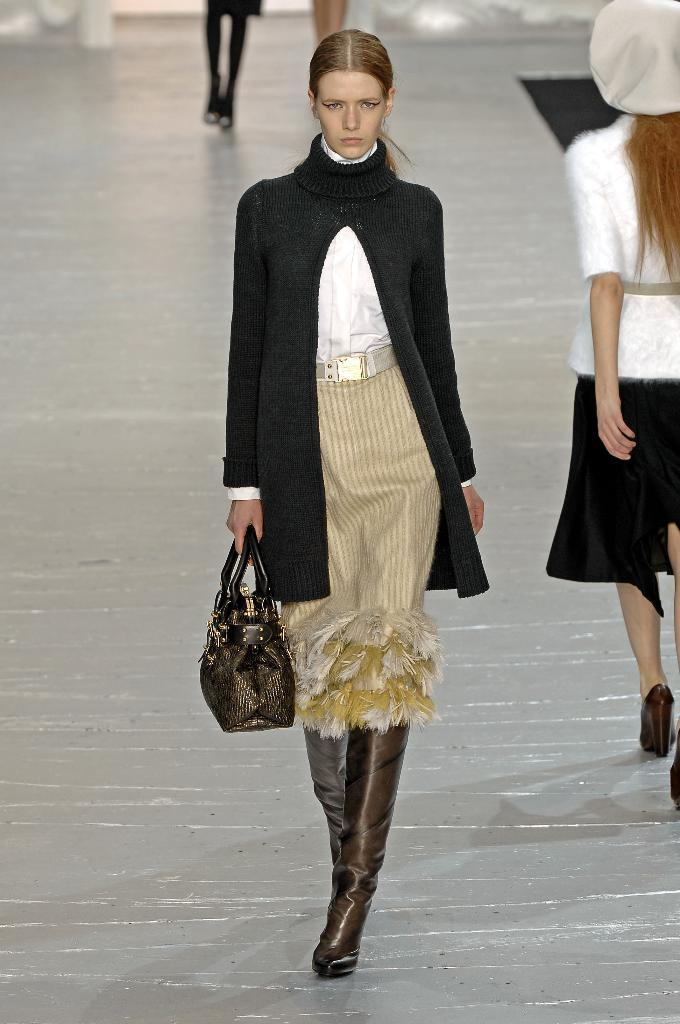Who is the main subject in the picture? There is a woman in the picture. What is the woman doing in the image? The woman is walking. What is the woman holding in her hand? The woman is holding a bag in her hand. What is the woman wearing in the image? The woman is wearing a black dress. What can be seen in the background of the image? There are people walking in the background of the image. What is the texture of the mom's dress in the image? There is no mention of a mom in the image, and the woman's dress is described as black, but not its texture. 